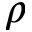<formula> <loc_0><loc_0><loc_500><loc_500>\rho</formula> 